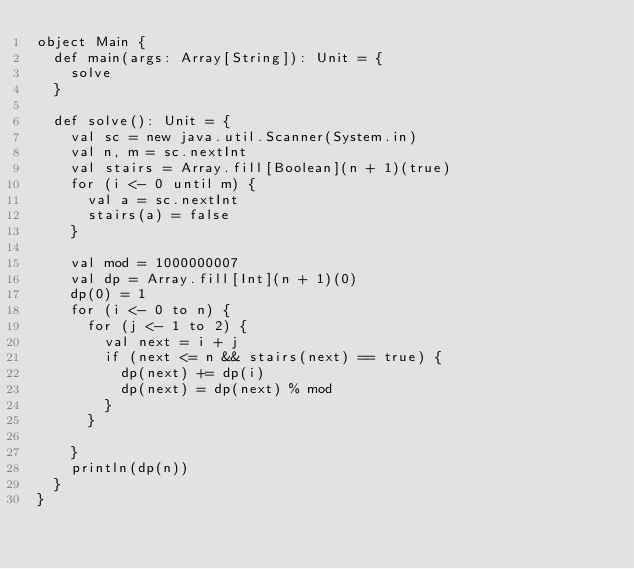<code> <loc_0><loc_0><loc_500><loc_500><_Scala_>object Main {
  def main(args: Array[String]): Unit = {
    solve
  }

  def solve(): Unit = {
    val sc = new java.util.Scanner(System.in)
    val n, m = sc.nextInt
    val stairs = Array.fill[Boolean](n + 1)(true)
    for (i <- 0 until m) {
      val a = sc.nextInt
      stairs(a) = false
    }

    val mod = 1000000007
    val dp = Array.fill[Int](n + 1)(0)
    dp(0) = 1
    for (i <- 0 to n) {
      for (j <- 1 to 2) {
        val next = i + j
        if (next <= n && stairs(next) == true) {
          dp(next) += dp(i)
          dp(next) = dp(next) % mod
        }
      }

    }
    println(dp(n))
  }
}
</code> 